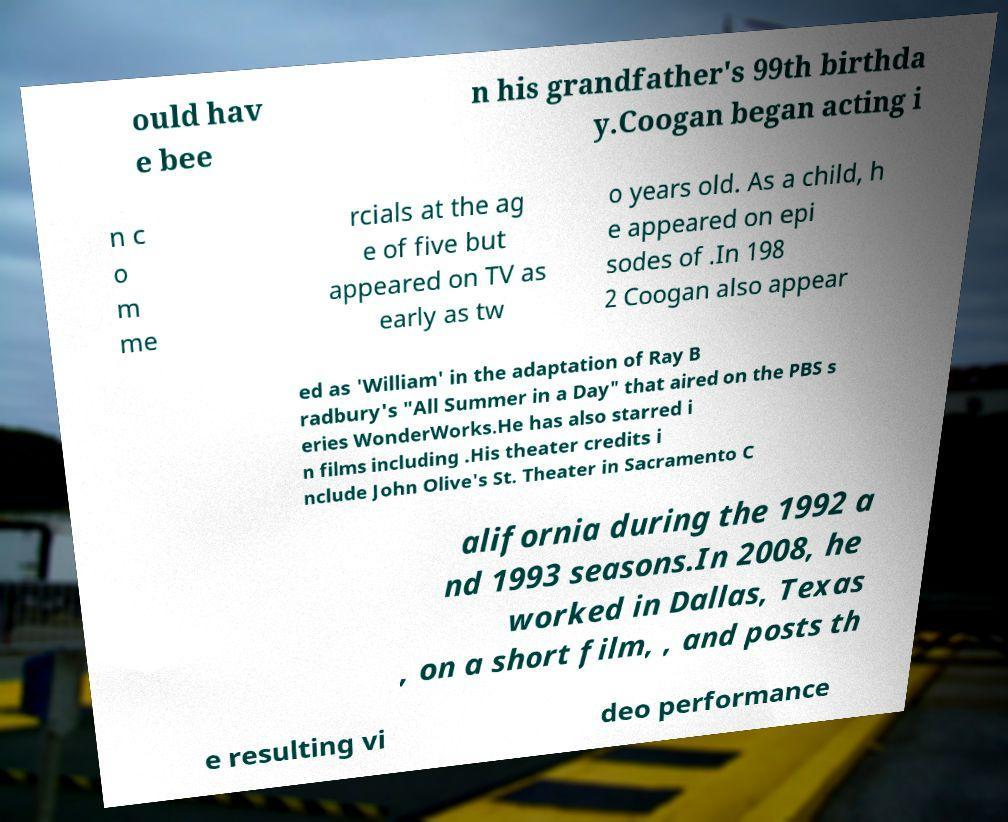I need the written content from this picture converted into text. Can you do that? ould hav e bee n his grandfather's 99th birthda y.Coogan began acting i n c o m me rcials at the ag e of five but appeared on TV as early as tw o years old. As a child, h e appeared on epi sodes of .In 198 2 Coogan also appear ed as 'William' in the adaptation of Ray B radbury's "All Summer in a Day" that aired on the PBS s eries WonderWorks.He has also starred i n films including .His theater credits i nclude John Olive's St. Theater in Sacramento C alifornia during the 1992 a nd 1993 seasons.In 2008, he worked in Dallas, Texas , on a short film, , and posts th e resulting vi deo performance 